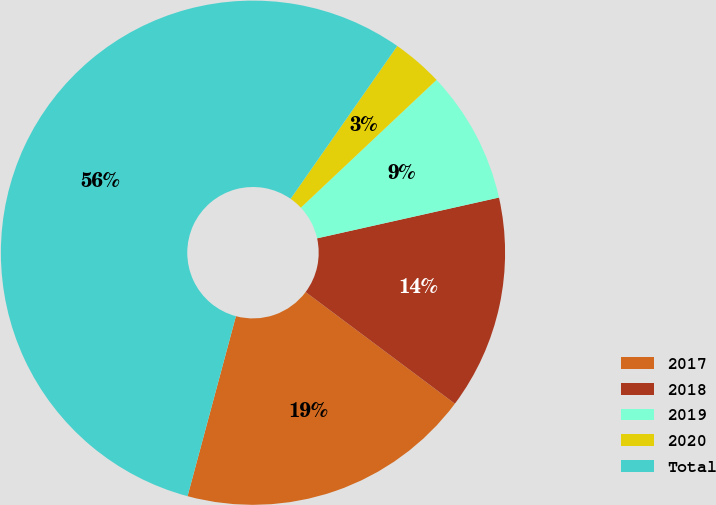<chart> <loc_0><loc_0><loc_500><loc_500><pie_chart><fcel>2017<fcel>2018<fcel>2019<fcel>2020<fcel>Total<nl><fcel>18.96%<fcel>13.73%<fcel>8.51%<fcel>3.28%<fcel>55.52%<nl></chart> 